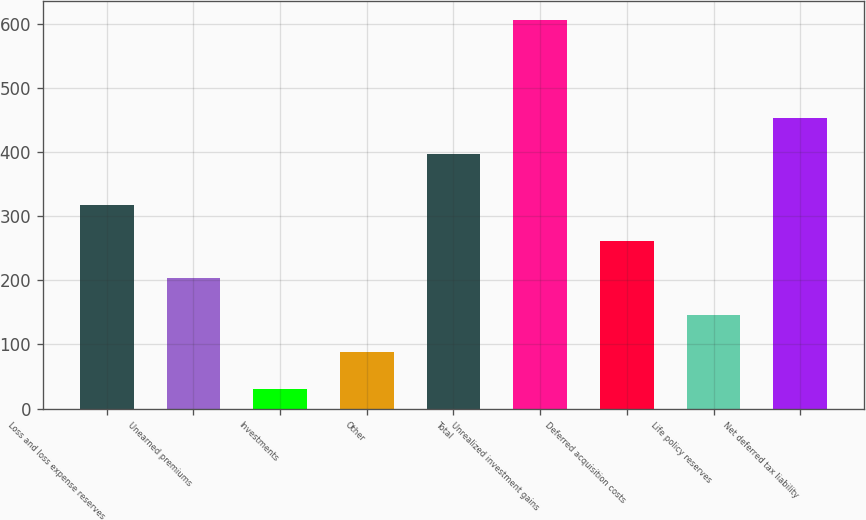Convert chart. <chart><loc_0><loc_0><loc_500><loc_500><bar_chart><fcel>Loss and loss expense reserves<fcel>Unearned premiums<fcel>Investments<fcel>Other<fcel>Total<fcel>Unrealized investment gains<fcel>Deferred acquisition costs<fcel>Life policy reserves<fcel>Net deferred tax liability<nl><fcel>318<fcel>203.2<fcel>31<fcel>88.4<fcel>396<fcel>605<fcel>260.6<fcel>145.8<fcel>453.4<nl></chart> 